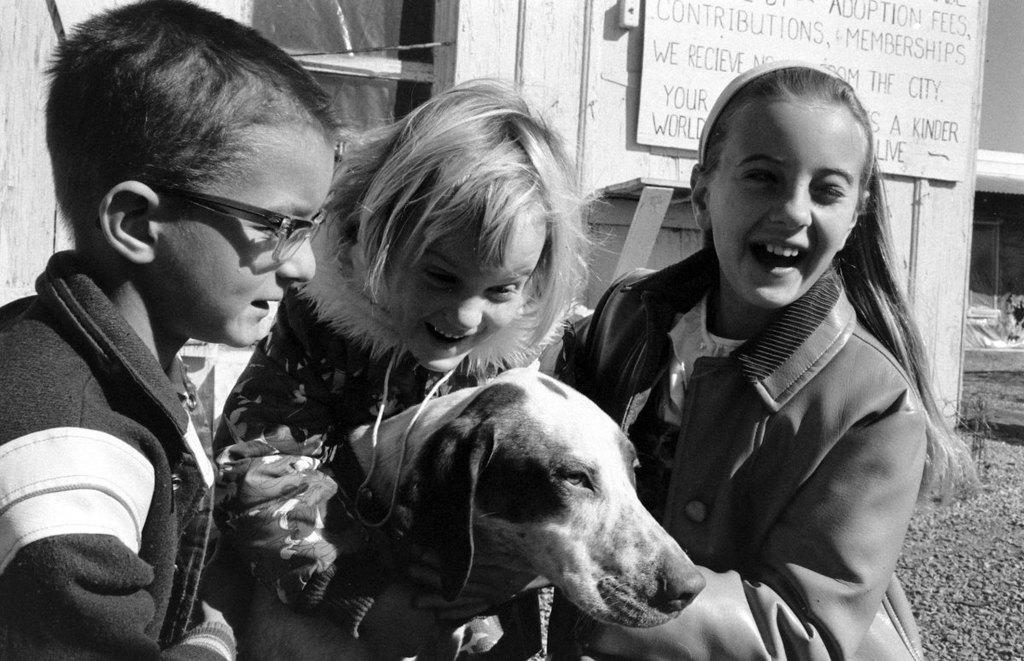What is the color scheme of the image? The image is black and white. How many children are present in the image? There are two girls and one boy in the image. What are the children doing in the image? The children are holding a dog. What can be seen in the background of the image? There is a board in the background of the image. Where is the board located in the image? The board is attached to a wall. What type of mask is the boy wearing in the image? There is no mask present in the image; the children are holding a dog. What book is the girl reading in the image? There is no book or reading activity depicted in the image. 